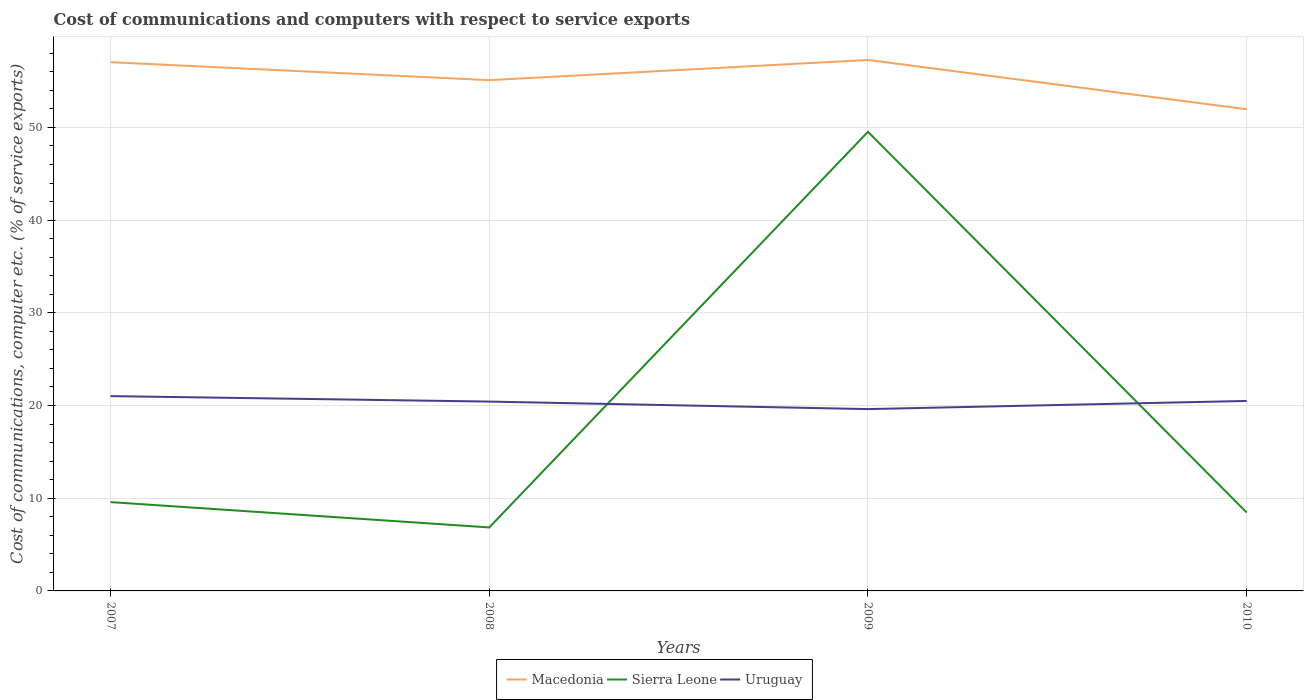How many different coloured lines are there?
Your response must be concise. 3. Does the line corresponding to Sierra Leone intersect with the line corresponding to Macedonia?
Make the answer very short. No. Is the number of lines equal to the number of legend labels?
Offer a terse response. Yes. Across all years, what is the maximum cost of communications and computers in Sierra Leone?
Offer a very short reply. 6.85. In which year was the cost of communications and computers in Uruguay maximum?
Your answer should be compact. 2009. What is the total cost of communications and computers in Sierra Leone in the graph?
Offer a terse response. 41.07. What is the difference between the highest and the second highest cost of communications and computers in Macedonia?
Provide a short and direct response. 5.32. What is the difference between the highest and the lowest cost of communications and computers in Uruguay?
Provide a succinct answer. 3. Is the cost of communications and computers in Sierra Leone strictly greater than the cost of communications and computers in Macedonia over the years?
Your answer should be compact. Yes. How many lines are there?
Provide a succinct answer. 3. How many years are there in the graph?
Provide a succinct answer. 4. Are the values on the major ticks of Y-axis written in scientific E-notation?
Your response must be concise. No. How many legend labels are there?
Your response must be concise. 3. What is the title of the graph?
Ensure brevity in your answer.  Cost of communications and computers with respect to service exports. Does "Europe(all income levels)" appear as one of the legend labels in the graph?
Keep it short and to the point. No. What is the label or title of the Y-axis?
Offer a very short reply. Cost of communications, computer etc. (% of service exports). What is the Cost of communications, computer etc. (% of service exports) of Macedonia in 2007?
Make the answer very short. 57.04. What is the Cost of communications, computer etc. (% of service exports) in Sierra Leone in 2007?
Ensure brevity in your answer.  9.58. What is the Cost of communications, computer etc. (% of service exports) of Uruguay in 2007?
Your response must be concise. 21.01. What is the Cost of communications, computer etc. (% of service exports) in Macedonia in 2008?
Make the answer very short. 55.1. What is the Cost of communications, computer etc. (% of service exports) of Sierra Leone in 2008?
Keep it short and to the point. 6.85. What is the Cost of communications, computer etc. (% of service exports) in Uruguay in 2008?
Offer a very short reply. 20.43. What is the Cost of communications, computer etc. (% of service exports) of Macedonia in 2009?
Ensure brevity in your answer.  57.28. What is the Cost of communications, computer etc. (% of service exports) in Sierra Leone in 2009?
Your answer should be very brief. 49.53. What is the Cost of communications, computer etc. (% of service exports) in Uruguay in 2009?
Offer a terse response. 19.61. What is the Cost of communications, computer etc. (% of service exports) in Macedonia in 2010?
Your answer should be compact. 51.96. What is the Cost of communications, computer etc. (% of service exports) in Sierra Leone in 2010?
Your answer should be compact. 8.46. What is the Cost of communications, computer etc. (% of service exports) in Uruguay in 2010?
Offer a very short reply. 20.49. Across all years, what is the maximum Cost of communications, computer etc. (% of service exports) in Macedonia?
Keep it short and to the point. 57.28. Across all years, what is the maximum Cost of communications, computer etc. (% of service exports) of Sierra Leone?
Offer a very short reply. 49.53. Across all years, what is the maximum Cost of communications, computer etc. (% of service exports) of Uruguay?
Keep it short and to the point. 21.01. Across all years, what is the minimum Cost of communications, computer etc. (% of service exports) in Macedonia?
Your response must be concise. 51.96. Across all years, what is the minimum Cost of communications, computer etc. (% of service exports) of Sierra Leone?
Provide a succinct answer. 6.85. Across all years, what is the minimum Cost of communications, computer etc. (% of service exports) of Uruguay?
Make the answer very short. 19.61. What is the total Cost of communications, computer etc. (% of service exports) of Macedonia in the graph?
Offer a terse response. 221.37. What is the total Cost of communications, computer etc. (% of service exports) in Sierra Leone in the graph?
Keep it short and to the point. 74.41. What is the total Cost of communications, computer etc. (% of service exports) in Uruguay in the graph?
Keep it short and to the point. 81.55. What is the difference between the Cost of communications, computer etc. (% of service exports) of Macedonia in 2007 and that in 2008?
Your answer should be compact. 1.94. What is the difference between the Cost of communications, computer etc. (% of service exports) in Sierra Leone in 2007 and that in 2008?
Make the answer very short. 2.73. What is the difference between the Cost of communications, computer etc. (% of service exports) of Uruguay in 2007 and that in 2008?
Offer a terse response. 0.59. What is the difference between the Cost of communications, computer etc. (% of service exports) of Macedonia in 2007 and that in 2009?
Ensure brevity in your answer.  -0.24. What is the difference between the Cost of communications, computer etc. (% of service exports) of Sierra Leone in 2007 and that in 2009?
Provide a short and direct response. -39.95. What is the difference between the Cost of communications, computer etc. (% of service exports) in Uruguay in 2007 and that in 2009?
Offer a very short reply. 1.4. What is the difference between the Cost of communications, computer etc. (% of service exports) in Macedonia in 2007 and that in 2010?
Keep it short and to the point. 5.08. What is the difference between the Cost of communications, computer etc. (% of service exports) in Sierra Leone in 2007 and that in 2010?
Provide a succinct answer. 1.12. What is the difference between the Cost of communications, computer etc. (% of service exports) in Uruguay in 2007 and that in 2010?
Provide a succinct answer. 0.52. What is the difference between the Cost of communications, computer etc. (% of service exports) in Macedonia in 2008 and that in 2009?
Provide a short and direct response. -2.18. What is the difference between the Cost of communications, computer etc. (% of service exports) of Sierra Leone in 2008 and that in 2009?
Offer a terse response. -42.68. What is the difference between the Cost of communications, computer etc. (% of service exports) of Uruguay in 2008 and that in 2009?
Give a very brief answer. 0.81. What is the difference between the Cost of communications, computer etc. (% of service exports) of Macedonia in 2008 and that in 2010?
Provide a short and direct response. 3.14. What is the difference between the Cost of communications, computer etc. (% of service exports) of Sierra Leone in 2008 and that in 2010?
Offer a very short reply. -1.61. What is the difference between the Cost of communications, computer etc. (% of service exports) of Uruguay in 2008 and that in 2010?
Make the answer very short. -0.07. What is the difference between the Cost of communications, computer etc. (% of service exports) in Macedonia in 2009 and that in 2010?
Ensure brevity in your answer.  5.32. What is the difference between the Cost of communications, computer etc. (% of service exports) in Sierra Leone in 2009 and that in 2010?
Offer a very short reply. 41.07. What is the difference between the Cost of communications, computer etc. (% of service exports) in Uruguay in 2009 and that in 2010?
Keep it short and to the point. -0.88. What is the difference between the Cost of communications, computer etc. (% of service exports) in Macedonia in 2007 and the Cost of communications, computer etc. (% of service exports) in Sierra Leone in 2008?
Keep it short and to the point. 50.19. What is the difference between the Cost of communications, computer etc. (% of service exports) of Macedonia in 2007 and the Cost of communications, computer etc. (% of service exports) of Uruguay in 2008?
Your answer should be compact. 36.61. What is the difference between the Cost of communications, computer etc. (% of service exports) of Sierra Leone in 2007 and the Cost of communications, computer etc. (% of service exports) of Uruguay in 2008?
Give a very brief answer. -10.85. What is the difference between the Cost of communications, computer etc. (% of service exports) in Macedonia in 2007 and the Cost of communications, computer etc. (% of service exports) in Sierra Leone in 2009?
Your answer should be very brief. 7.51. What is the difference between the Cost of communications, computer etc. (% of service exports) of Macedonia in 2007 and the Cost of communications, computer etc. (% of service exports) of Uruguay in 2009?
Your answer should be very brief. 37.42. What is the difference between the Cost of communications, computer etc. (% of service exports) in Sierra Leone in 2007 and the Cost of communications, computer etc. (% of service exports) in Uruguay in 2009?
Offer a very short reply. -10.03. What is the difference between the Cost of communications, computer etc. (% of service exports) of Macedonia in 2007 and the Cost of communications, computer etc. (% of service exports) of Sierra Leone in 2010?
Your response must be concise. 48.58. What is the difference between the Cost of communications, computer etc. (% of service exports) of Macedonia in 2007 and the Cost of communications, computer etc. (% of service exports) of Uruguay in 2010?
Offer a very short reply. 36.54. What is the difference between the Cost of communications, computer etc. (% of service exports) in Sierra Leone in 2007 and the Cost of communications, computer etc. (% of service exports) in Uruguay in 2010?
Offer a terse response. -10.91. What is the difference between the Cost of communications, computer etc. (% of service exports) in Macedonia in 2008 and the Cost of communications, computer etc. (% of service exports) in Sierra Leone in 2009?
Provide a succinct answer. 5.57. What is the difference between the Cost of communications, computer etc. (% of service exports) of Macedonia in 2008 and the Cost of communications, computer etc. (% of service exports) of Uruguay in 2009?
Your answer should be very brief. 35.49. What is the difference between the Cost of communications, computer etc. (% of service exports) in Sierra Leone in 2008 and the Cost of communications, computer etc. (% of service exports) in Uruguay in 2009?
Provide a short and direct response. -12.77. What is the difference between the Cost of communications, computer etc. (% of service exports) in Macedonia in 2008 and the Cost of communications, computer etc. (% of service exports) in Sierra Leone in 2010?
Give a very brief answer. 46.64. What is the difference between the Cost of communications, computer etc. (% of service exports) in Macedonia in 2008 and the Cost of communications, computer etc. (% of service exports) in Uruguay in 2010?
Offer a very short reply. 34.61. What is the difference between the Cost of communications, computer etc. (% of service exports) of Sierra Leone in 2008 and the Cost of communications, computer etc. (% of service exports) of Uruguay in 2010?
Your answer should be compact. -13.65. What is the difference between the Cost of communications, computer etc. (% of service exports) of Macedonia in 2009 and the Cost of communications, computer etc. (% of service exports) of Sierra Leone in 2010?
Your answer should be very brief. 48.82. What is the difference between the Cost of communications, computer etc. (% of service exports) of Macedonia in 2009 and the Cost of communications, computer etc. (% of service exports) of Uruguay in 2010?
Your answer should be very brief. 36.78. What is the difference between the Cost of communications, computer etc. (% of service exports) in Sierra Leone in 2009 and the Cost of communications, computer etc. (% of service exports) in Uruguay in 2010?
Make the answer very short. 29.03. What is the average Cost of communications, computer etc. (% of service exports) in Macedonia per year?
Provide a succinct answer. 55.34. What is the average Cost of communications, computer etc. (% of service exports) of Sierra Leone per year?
Provide a succinct answer. 18.6. What is the average Cost of communications, computer etc. (% of service exports) in Uruguay per year?
Ensure brevity in your answer.  20.39. In the year 2007, what is the difference between the Cost of communications, computer etc. (% of service exports) in Macedonia and Cost of communications, computer etc. (% of service exports) in Sierra Leone?
Give a very brief answer. 47.46. In the year 2007, what is the difference between the Cost of communications, computer etc. (% of service exports) in Macedonia and Cost of communications, computer etc. (% of service exports) in Uruguay?
Offer a terse response. 36.02. In the year 2007, what is the difference between the Cost of communications, computer etc. (% of service exports) of Sierra Leone and Cost of communications, computer etc. (% of service exports) of Uruguay?
Offer a terse response. -11.43. In the year 2008, what is the difference between the Cost of communications, computer etc. (% of service exports) in Macedonia and Cost of communications, computer etc. (% of service exports) in Sierra Leone?
Offer a terse response. 48.25. In the year 2008, what is the difference between the Cost of communications, computer etc. (% of service exports) in Macedonia and Cost of communications, computer etc. (% of service exports) in Uruguay?
Your response must be concise. 34.67. In the year 2008, what is the difference between the Cost of communications, computer etc. (% of service exports) of Sierra Leone and Cost of communications, computer etc. (% of service exports) of Uruguay?
Provide a short and direct response. -13.58. In the year 2009, what is the difference between the Cost of communications, computer etc. (% of service exports) of Macedonia and Cost of communications, computer etc. (% of service exports) of Sierra Leone?
Provide a short and direct response. 7.75. In the year 2009, what is the difference between the Cost of communications, computer etc. (% of service exports) in Macedonia and Cost of communications, computer etc. (% of service exports) in Uruguay?
Make the answer very short. 37.66. In the year 2009, what is the difference between the Cost of communications, computer etc. (% of service exports) of Sierra Leone and Cost of communications, computer etc. (% of service exports) of Uruguay?
Offer a very short reply. 29.91. In the year 2010, what is the difference between the Cost of communications, computer etc. (% of service exports) of Macedonia and Cost of communications, computer etc. (% of service exports) of Sierra Leone?
Provide a short and direct response. 43.5. In the year 2010, what is the difference between the Cost of communications, computer etc. (% of service exports) in Macedonia and Cost of communications, computer etc. (% of service exports) in Uruguay?
Offer a terse response. 31.46. In the year 2010, what is the difference between the Cost of communications, computer etc. (% of service exports) in Sierra Leone and Cost of communications, computer etc. (% of service exports) in Uruguay?
Give a very brief answer. -12.04. What is the ratio of the Cost of communications, computer etc. (% of service exports) in Macedonia in 2007 to that in 2008?
Provide a short and direct response. 1.04. What is the ratio of the Cost of communications, computer etc. (% of service exports) of Sierra Leone in 2007 to that in 2008?
Provide a succinct answer. 1.4. What is the ratio of the Cost of communications, computer etc. (% of service exports) of Uruguay in 2007 to that in 2008?
Give a very brief answer. 1.03. What is the ratio of the Cost of communications, computer etc. (% of service exports) in Sierra Leone in 2007 to that in 2009?
Your answer should be compact. 0.19. What is the ratio of the Cost of communications, computer etc. (% of service exports) of Uruguay in 2007 to that in 2009?
Provide a short and direct response. 1.07. What is the ratio of the Cost of communications, computer etc. (% of service exports) in Macedonia in 2007 to that in 2010?
Provide a short and direct response. 1.1. What is the ratio of the Cost of communications, computer etc. (% of service exports) in Sierra Leone in 2007 to that in 2010?
Keep it short and to the point. 1.13. What is the ratio of the Cost of communications, computer etc. (% of service exports) in Uruguay in 2007 to that in 2010?
Make the answer very short. 1.03. What is the ratio of the Cost of communications, computer etc. (% of service exports) of Macedonia in 2008 to that in 2009?
Offer a very short reply. 0.96. What is the ratio of the Cost of communications, computer etc. (% of service exports) in Sierra Leone in 2008 to that in 2009?
Ensure brevity in your answer.  0.14. What is the ratio of the Cost of communications, computer etc. (% of service exports) of Uruguay in 2008 to that in 2009?
Provide a succinct answer. 1.04. What is the ratio of the Cost of communications, computer etc. (% of service exports) in Macedonia in 2008 to that in 2010?
Make the answer very short. 1.06. What is the ratio of the Cost of communications, computer etc. (% of service exports) of Sierra Leone in 2008 to that in 2010?
Keep it short and to the point. 0.81. What is the ratio of the Cost of communications, computer etc. (% of service exports) in Macedonia in 2009 to that in 2010?
Make the answer very short. 1.1. What is the ratio of the Cost of communications, computer etc. (% of service exports) of Sierra Leone in 2009 to that in 2010?
Make the answer very short. 5.86. What is the ratio of the Cost of communications, computer etc. (% of service exports) in Uruguay in 2009 to that in 2010?
Your answer should be compact. 0.96. What is the difference between the highest and the second highest Cost of communications, computer etc. (% of service exports) in Macedonia?
Provide a succinct answer. 0.24. What is the difference between the highest and the second highest Cost of communications, computer etc. (% of service exports) in Sierra Leone?
Provide a succinct answer. 39.95. What is the difference between the highest and the second highest Cost of communications, computer etc. (% of service exports) in Uruguay?
Your answer should be compact. 0.52. What is the difference between the highest and the lowest Cost of communications, computer etc. (% of service exports) in Macedonia?
Give a very brief answer. 5.32. What is the difference between the highest and the lowest Cost of communications, computer etc. (% of service exports) in Sierra Leone?
Your answer should be very brief. 42.68. What is the difference between the highest and the lowest Cost of communications, computer etc. (% of service exports) in Uruguay?
Your response must be concise. 1.4. 